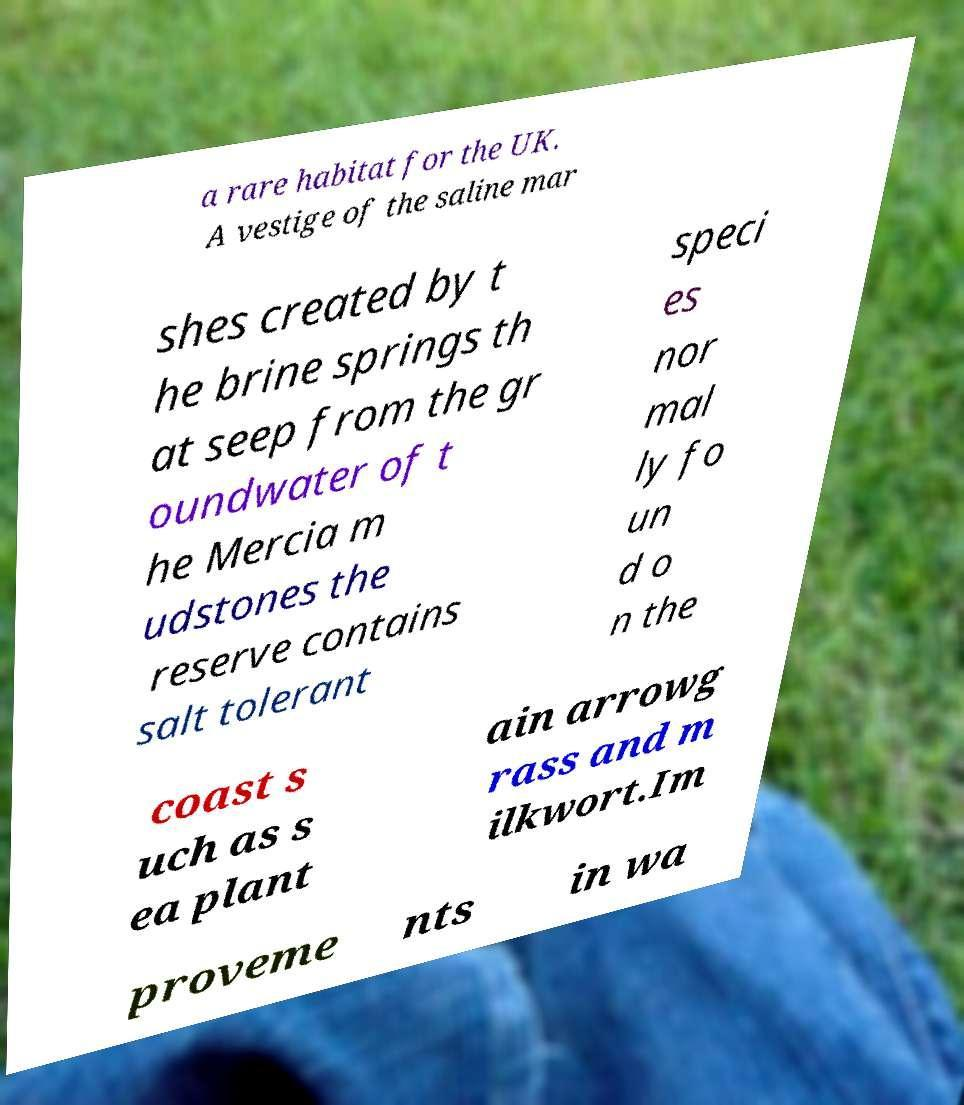Can you accurately transcribe the text from the provided image for me? a rare habitat for the UK. A vestige of the saline mar shes created by t he brine springs th at seep from the gr oundwater of t he Mercia m udstones the reserve contains salt tolerant speci es nor mal ly fo un d o n the coast s uch as s ea plant ain arrowg rass and m ilkwort.Im proveme nts in wa 